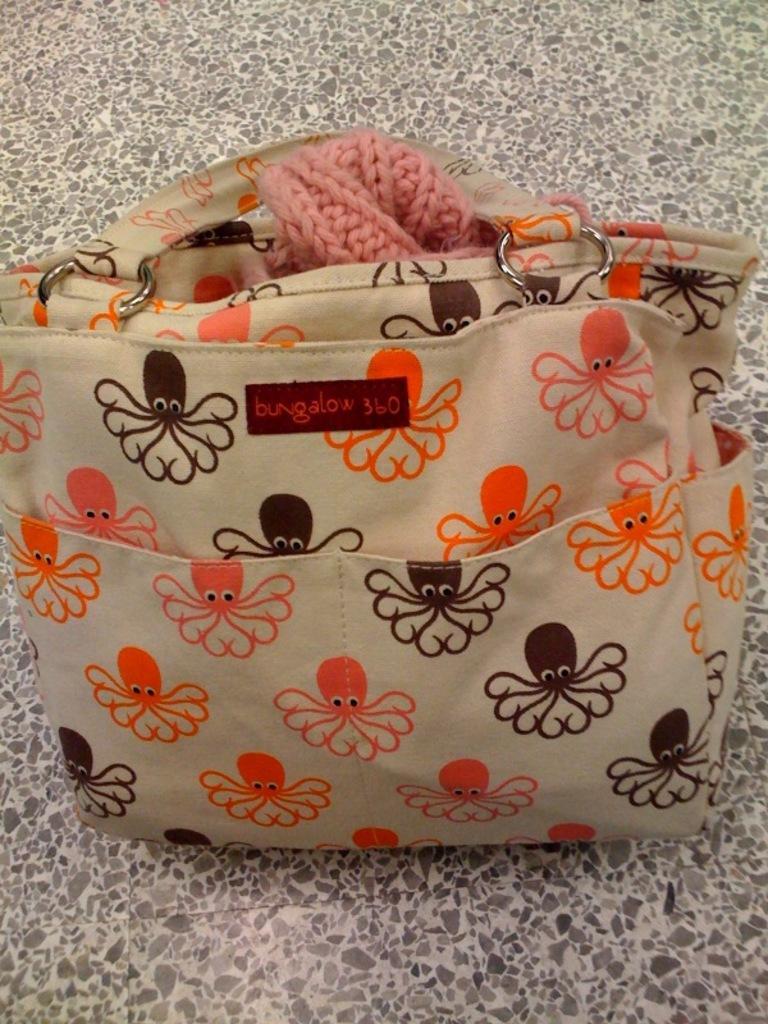How would you summarize this image in a sentence or two? This is a handbag and we can see some designs on it. 